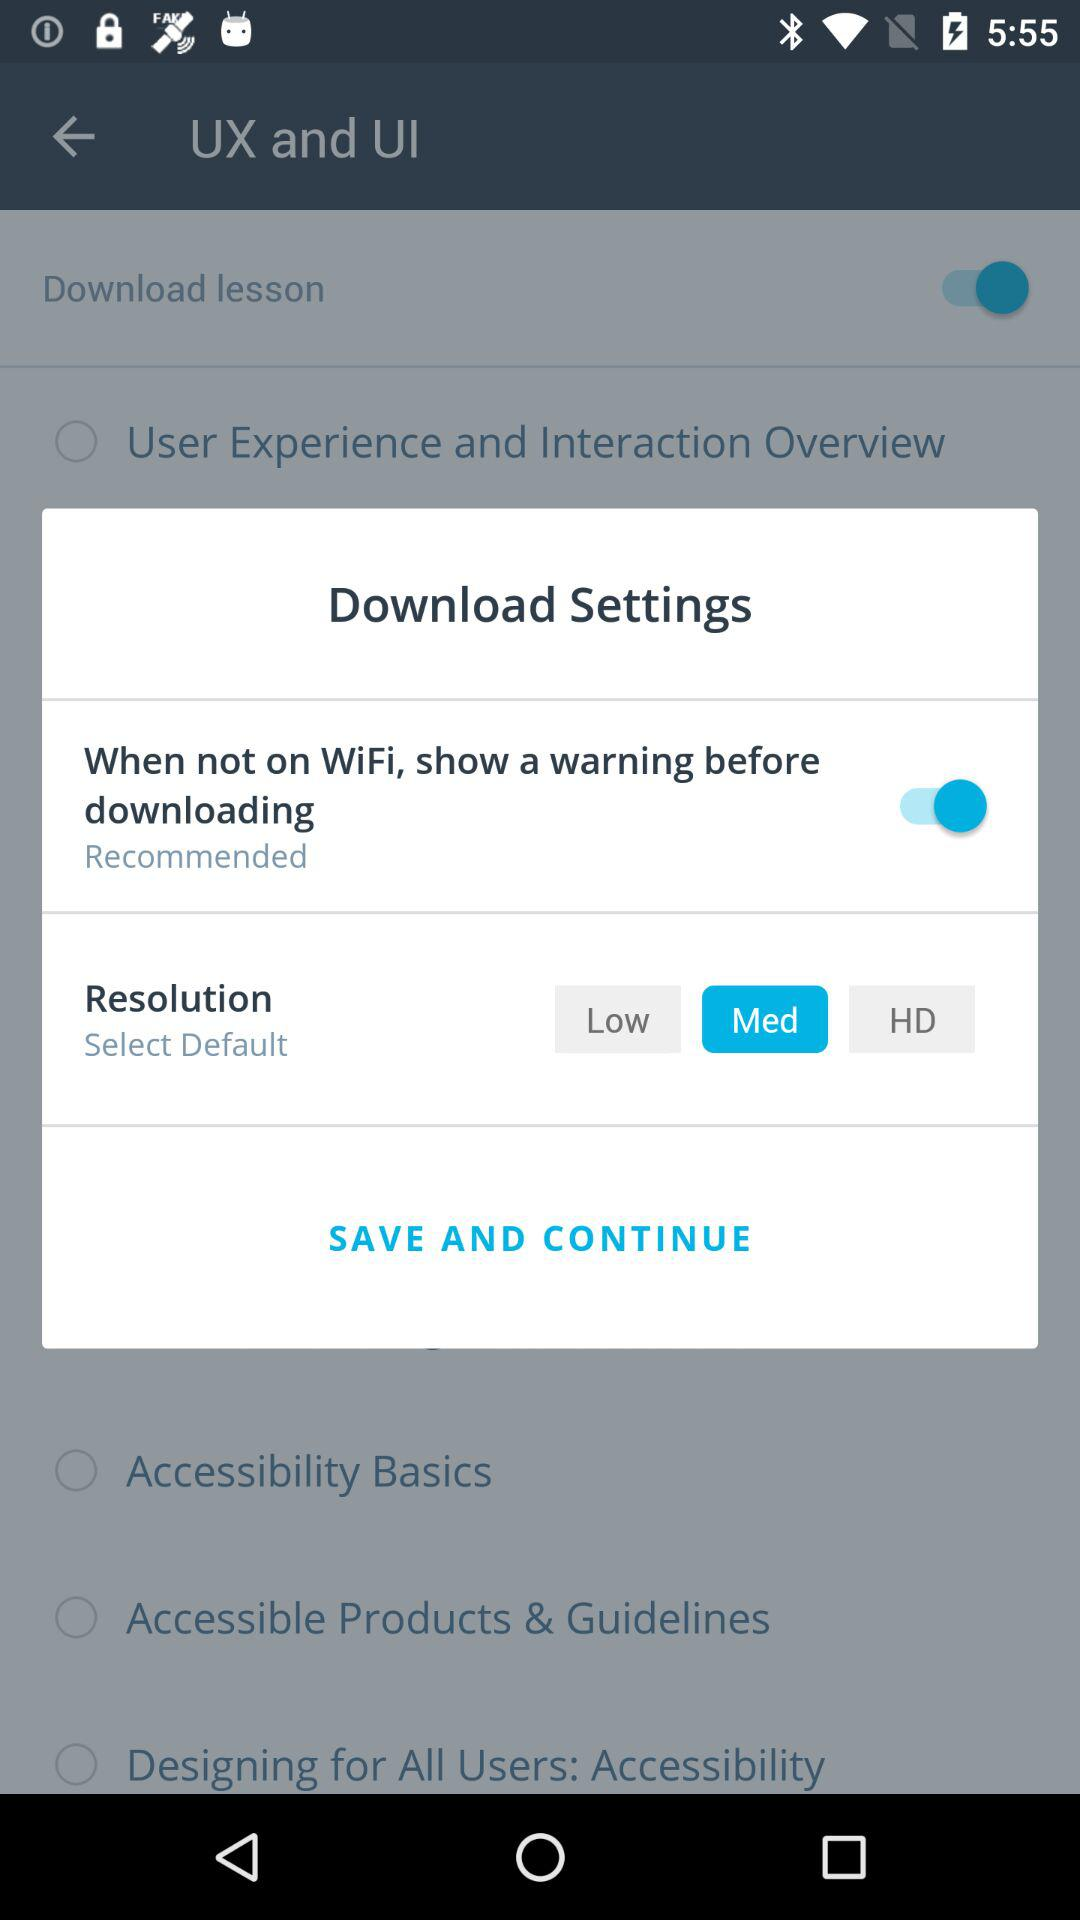How many resolutions does the user have to choose from?
Answer the question using a single word or phrase. 3 